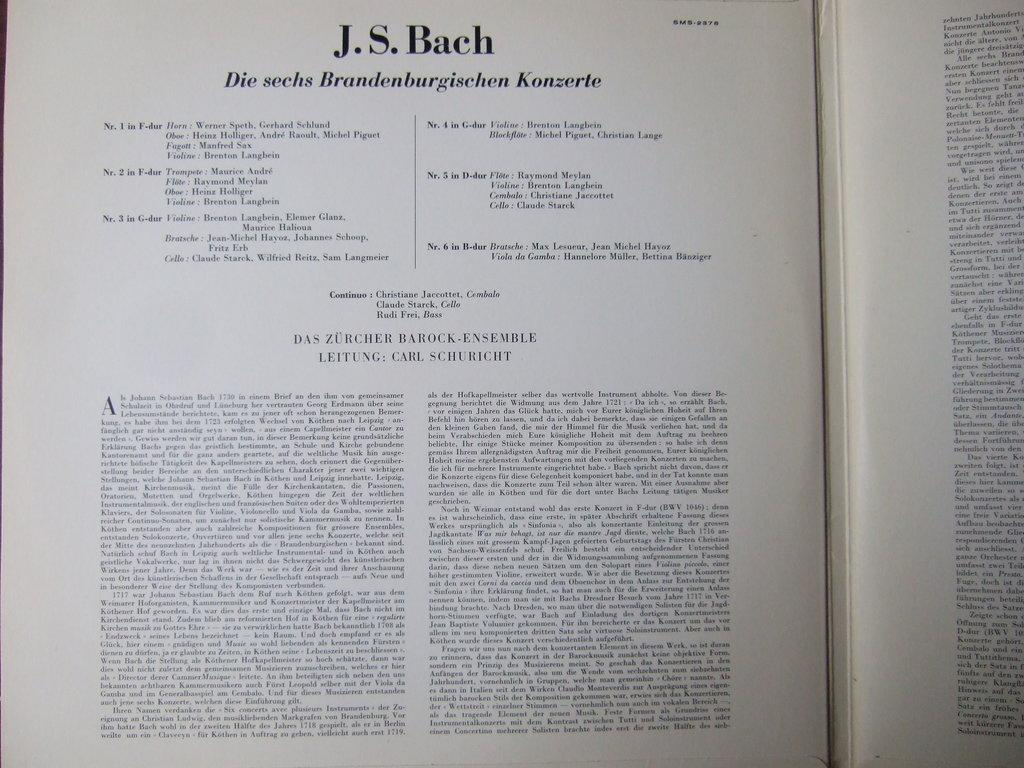<image>
Offer a succinct explanation of the picture presented. A book about J.S. Bach is written in a language other than English. 